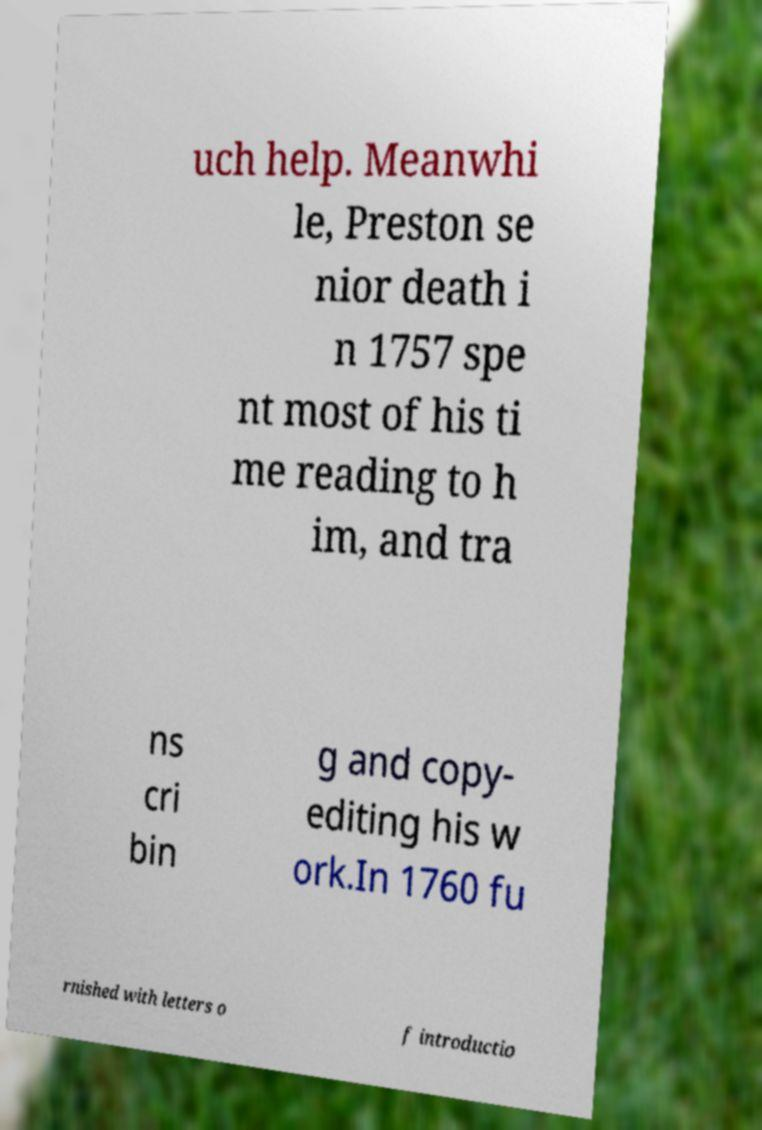Could you assist in decoding the text presented in this image and type it out clearly? uch help. Meanwhi le, Preston se nior death i n 1757 spe nt most of his ti me reading to h im, and tra ns cri bin g and copy- editing his w ork.In 1760 fu rnished with letters o f introductio 